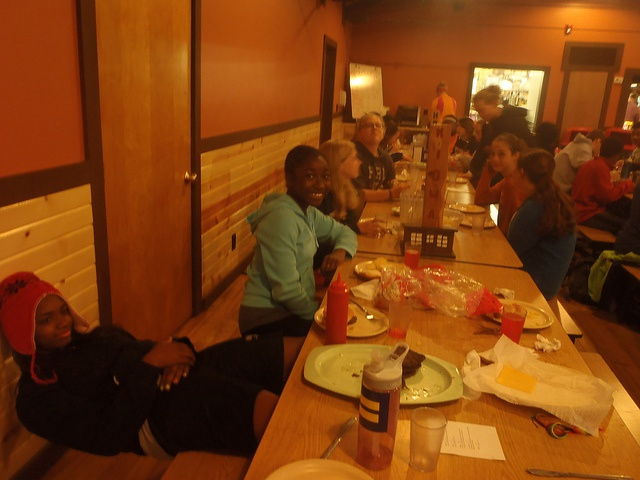Describe the objects in this image and their specific colors. I can see dining table in brown, red, orange, and maroon tones, people in brown, black, and maroon tones, people in brown, olive, black, and maroon tones, dining table in brown, maroon, and tan tones, and people in brown, black, and maroon tones in this image. 